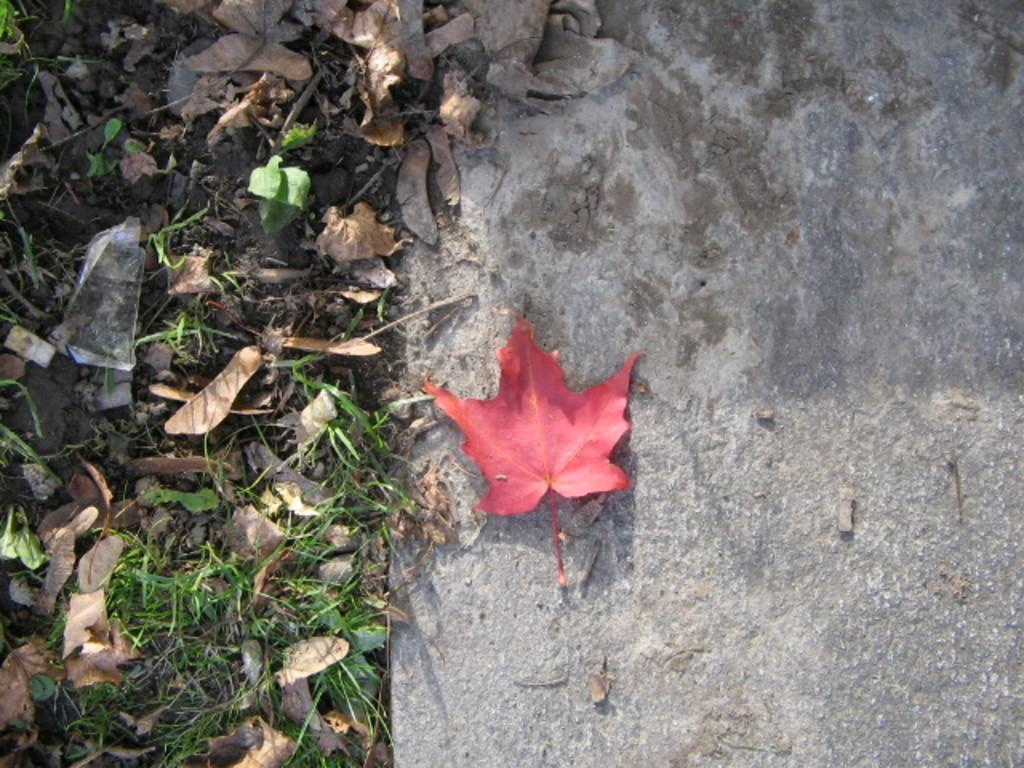What type of vegetation is present in the image? There is grass in the image. What else can be seen on the ground in the image? There are dried leaves on the ground in the image. How many drawers are visible in the image? There are no drawers present in the image. What type of account is being discussed in the image? There is no account being discussed in the image. 